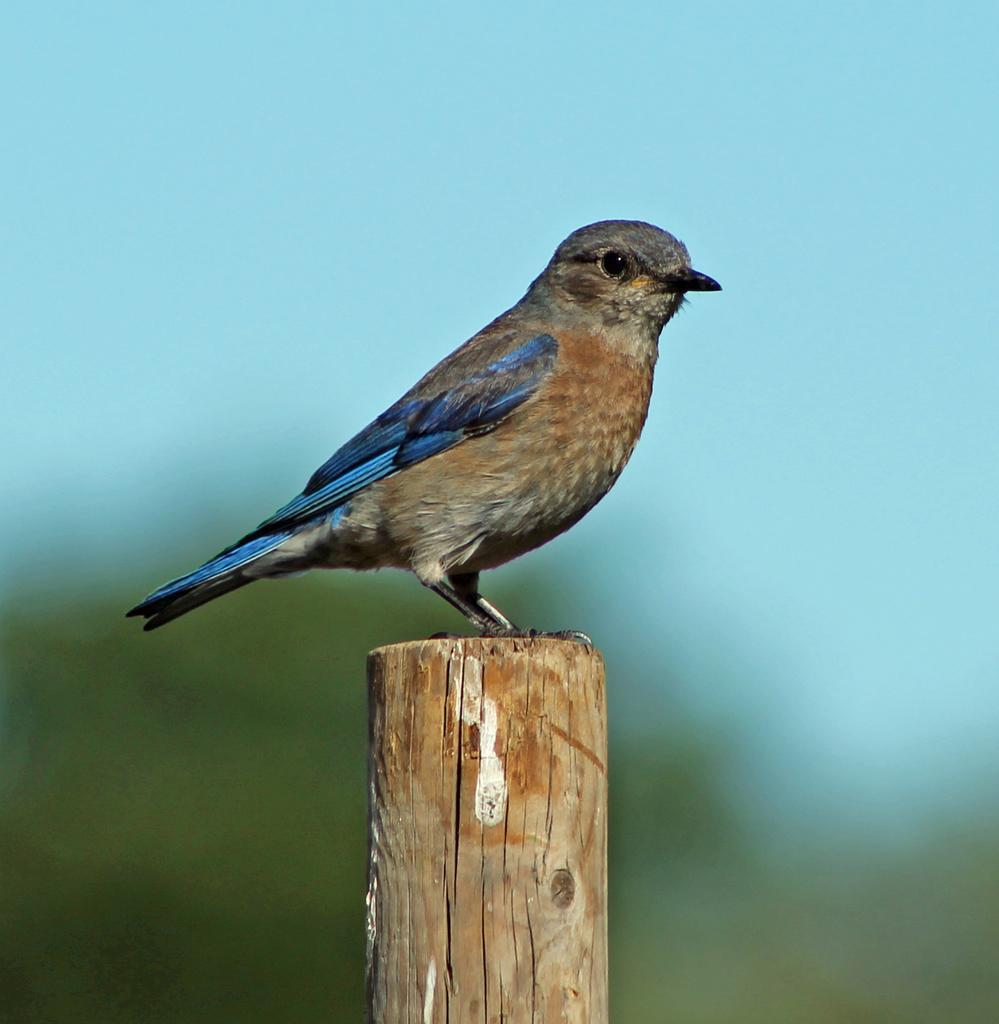Describe this image in one or two sentences. In the picture we can see a bird standing on the wooden pole and in the background we can see plants and sky which are invisible. 